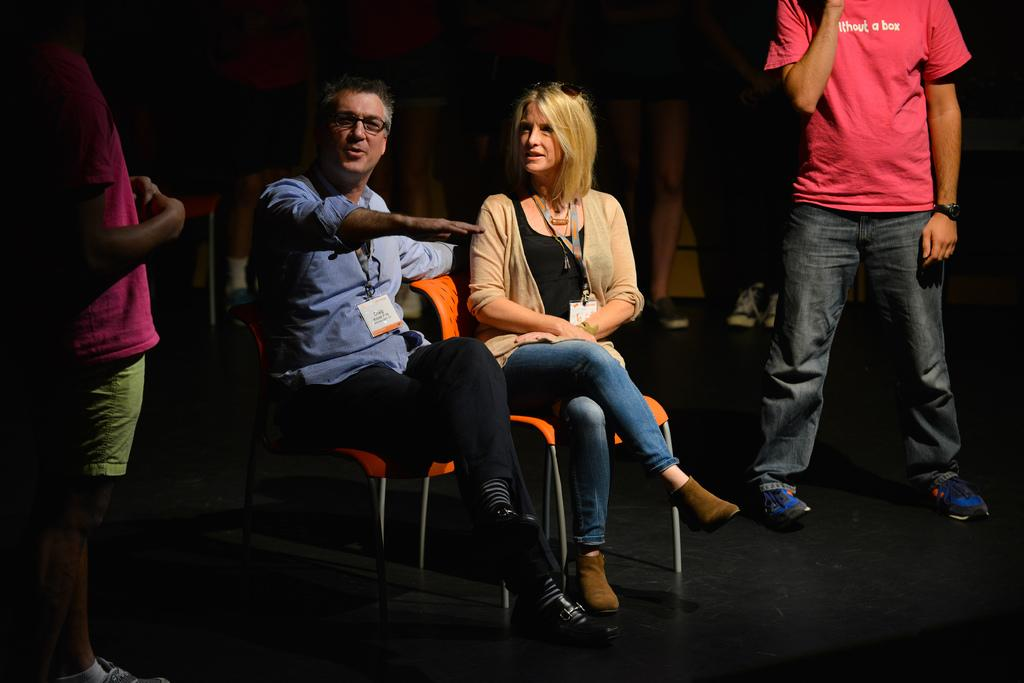How many people are present in the image? There are four people in the image, two sitting and two standing. What are the people wearing? The people are wearing clothes and shoes. What type of furniture is in the image? There are chairs in the image. What is the color of the chairs and surfaces in the image? The chairs and surfaces are black in color. What type of creature is sitting on the cactus in the image? There is no creature sitting on a cactus in the image; there are only people and furniture. Where can you buy the chairs and surfaces in the image? The image does not provide information about where to buy the chairs and surfaces, nor is there a store present in the image. 